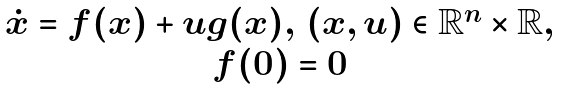Convert formula to latex. <formula><loc_0><loc_0><loc_500><loc_500>\begin{array} { c } \dot { x } = f ( x ) + u g ( x ) , \, ( x , u ) \in \mathbb { R } ^ { n } \times \mathbb { R } , \\ f ( 0 ) = 0 \end{array}</formula> 